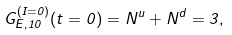Convert formula to latex. <formula><loc_0><loc_0><loc_500><loc_500>G _ { E , 1 0 } ^ { ( I = 0 ) } ( t = 0 ) = N ^ { u } + N ^ { d } = 3 ,</formula> 